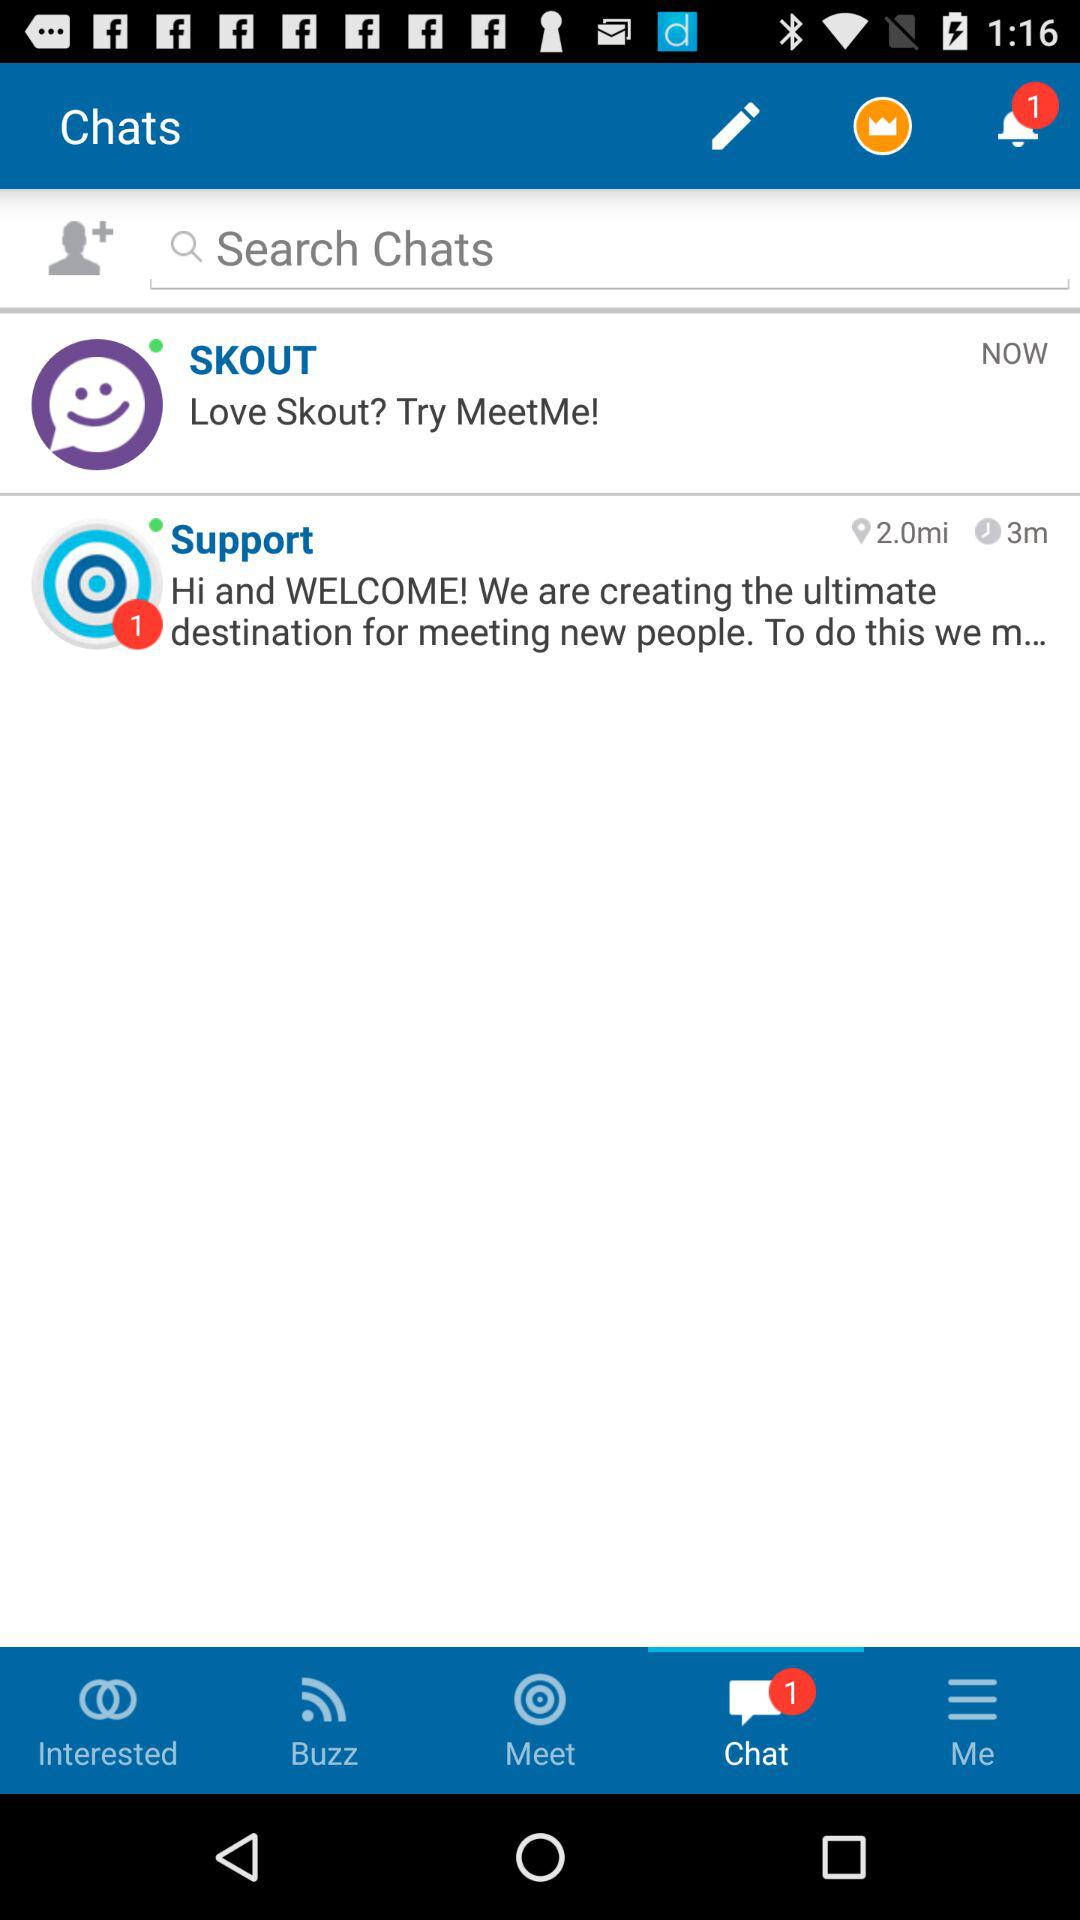What is the distance? The distance is 2.0 miles. 